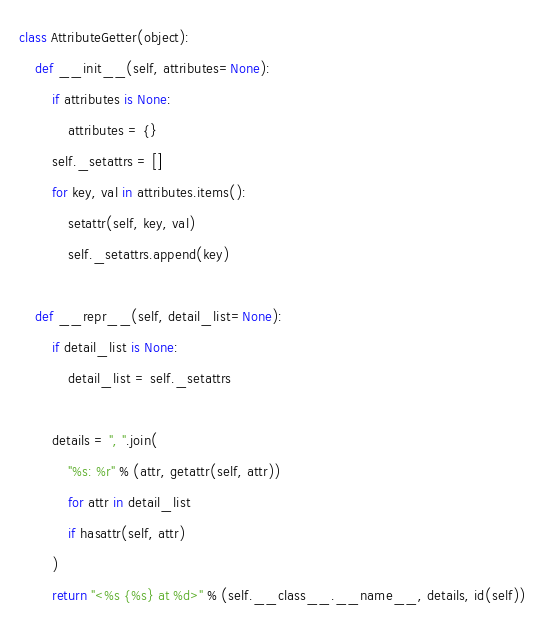<code> <loc_0><loc_0><loc_500><loc_500><_Python_>class AttributeGetter(object):
    def __init__(self, attributes=None):
        if attributes is None:
            attributes = {}
        self._setattrs = []
        for key, val in attributes.items():
            setattr(self, key, val)
            self._setattrs.append(key)

    def __repr__(self, detail_list=None):
        if detail_list is None:
            detail_list = self._setattrs

        details = ", ".join(
            "%s: %r" % (attr, getattr(self, attr))
            for attr in detail_list
            if hasattr(self, attr)
        )
        return "<%s {%s} at %d>" % (self.__class__.__name__, details, id(self))
</code> 